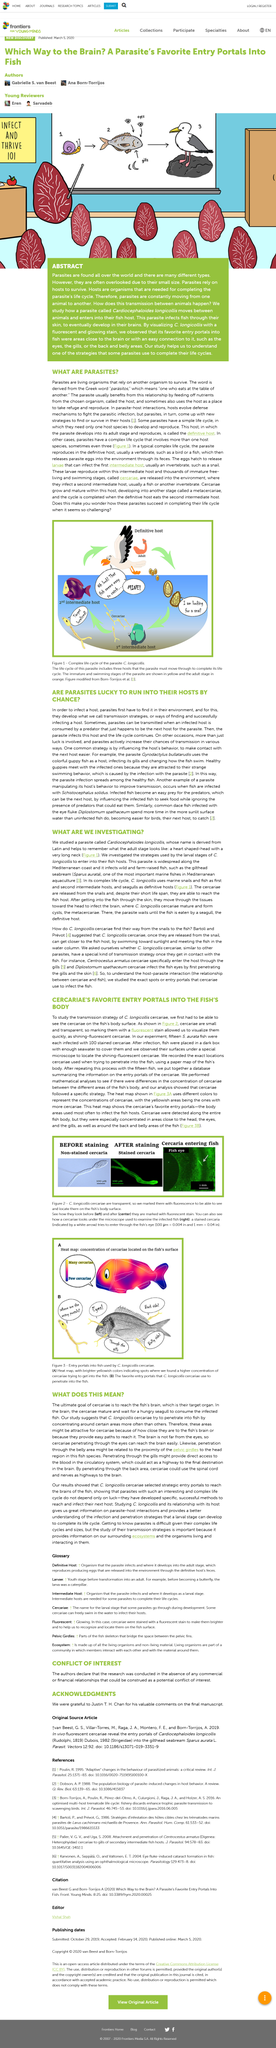Identify some key points in this picture. In the experiment, the number of fish that were infected with 100 stained cercariae was x, and the number of fish that were infected with 100 stained cercariae was y. The Greek word "parasite" is derived from "parasitos," which means "one who eats at the table of another." C. longicollis cercariae use various methods to penetrate into fish, including the eyes, belly, gills, and back area. These invasive cercariae are commonly found in freshwater habitats and have a significant impact on the fish populations in these areas. The cercariae of the white spot syndrome virus (WSSV) transmitter/marker C. longicollis were fluorescently labeled to enable visualization and tracking of their movement on the surface of infected fish. The C. longicollis cercariae is a parasite that infects the digestive system of various species of fish. It is not an organism in itself, but rather a stage in the life cycle of another organism. 